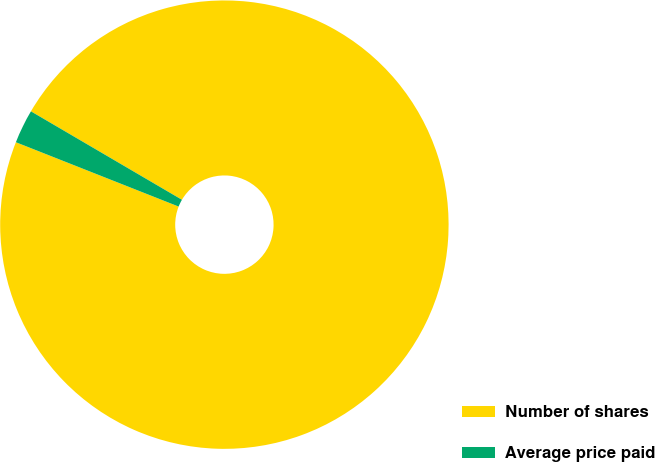Convert chart. <chart><loc_0><loc_0><loc_500><loc_500><pie_chart><fcel>Number of shares<fcel>Average price paid<nl><fcel>97.56%<fcel>2.44%<nl></chart> 